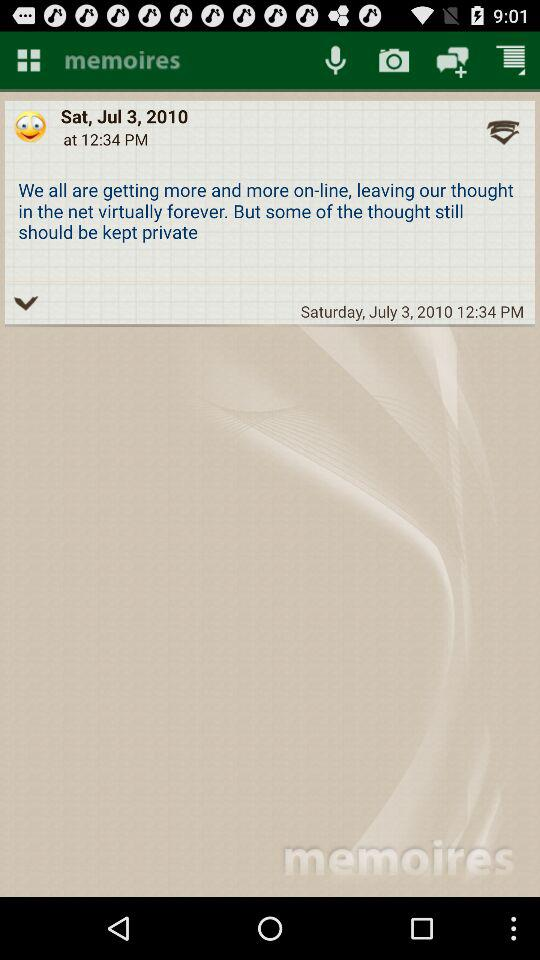What is the date and time? The date is Saturday, July 3, 2010, and the time is 12:34 p.m. 